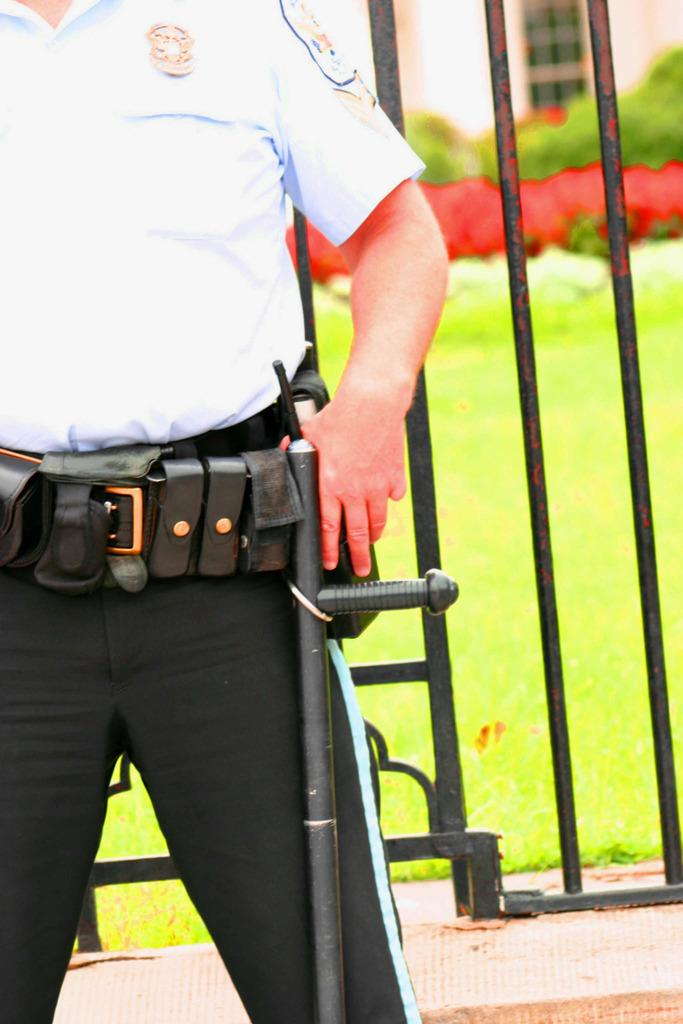What type of vegetation can be seen in the background of the image? There is grass in the background of the image. What objects are present in the image that are typically used for cooking? There are black grills in the image. Where is the man located in the image? The man is standing on the right side of the image. What type of lettuce is growing in the river in the image? There is no lettuce or river present in the image. Can you tell me what letter the man is holding in the image? There is no letter present in the image; the man is simply standing on the right side. 